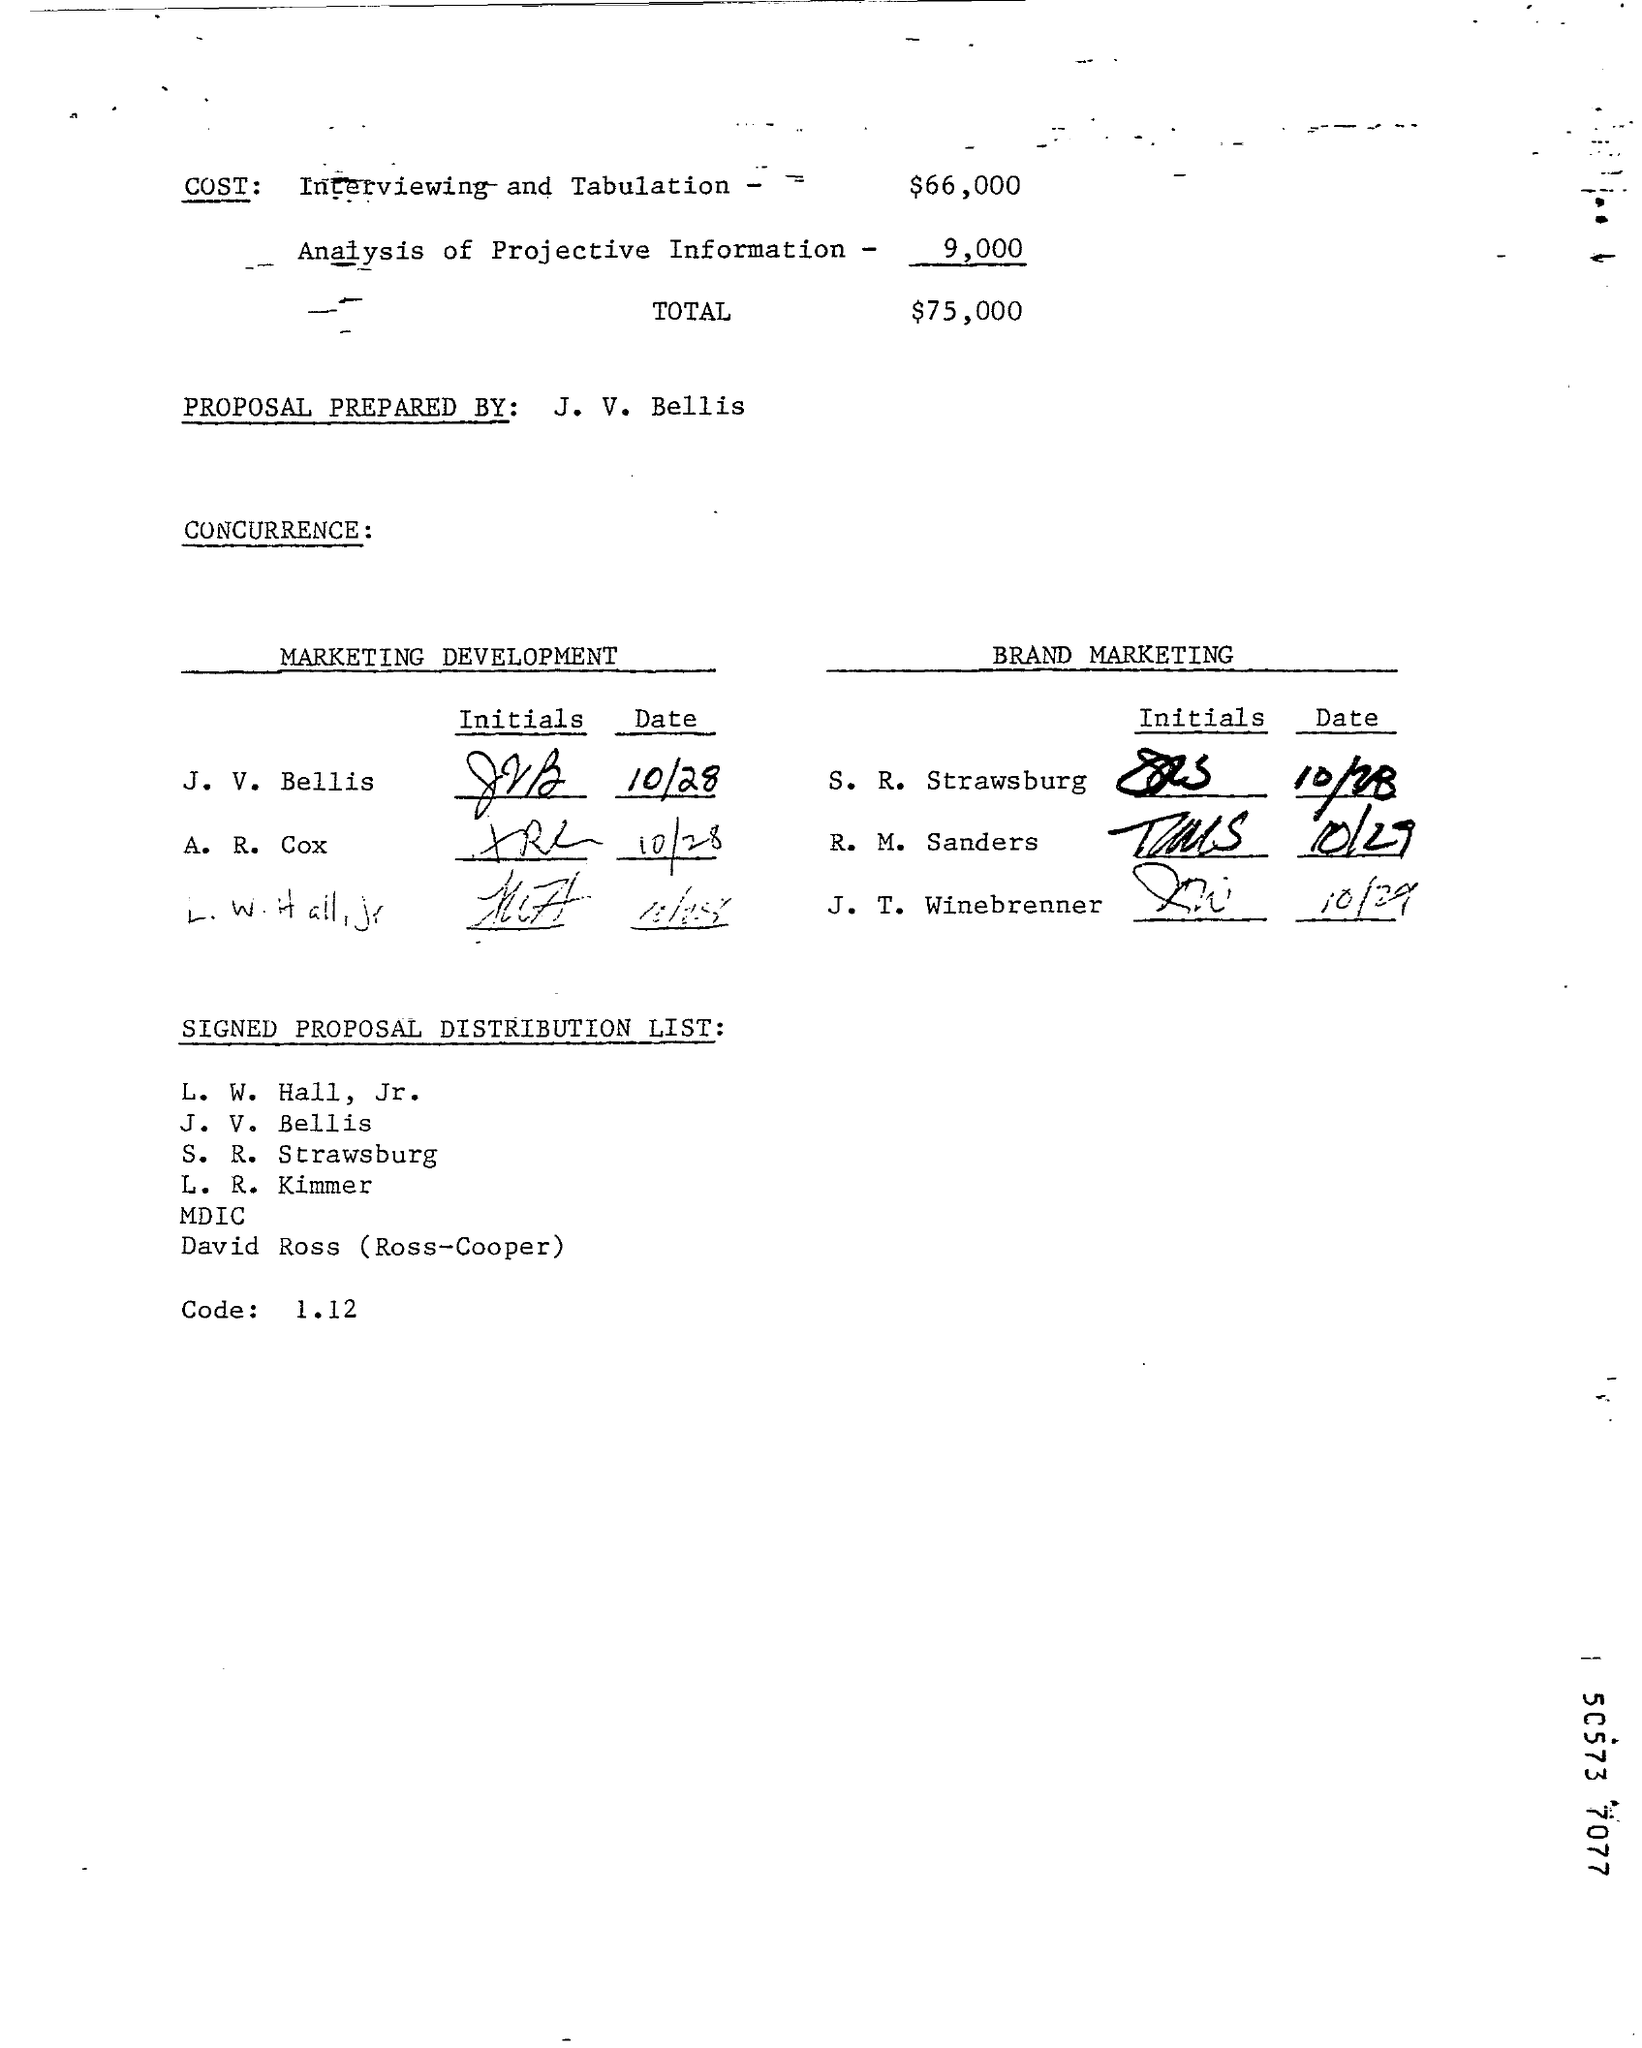Point out several critical features in this image. The total cost is $75,000. The proposal was prepared by J. V. Bellis. The cost of analysis of projective information is approximately 9,000. The cost of interviewing and tabulation is estimated to be $66,000. 